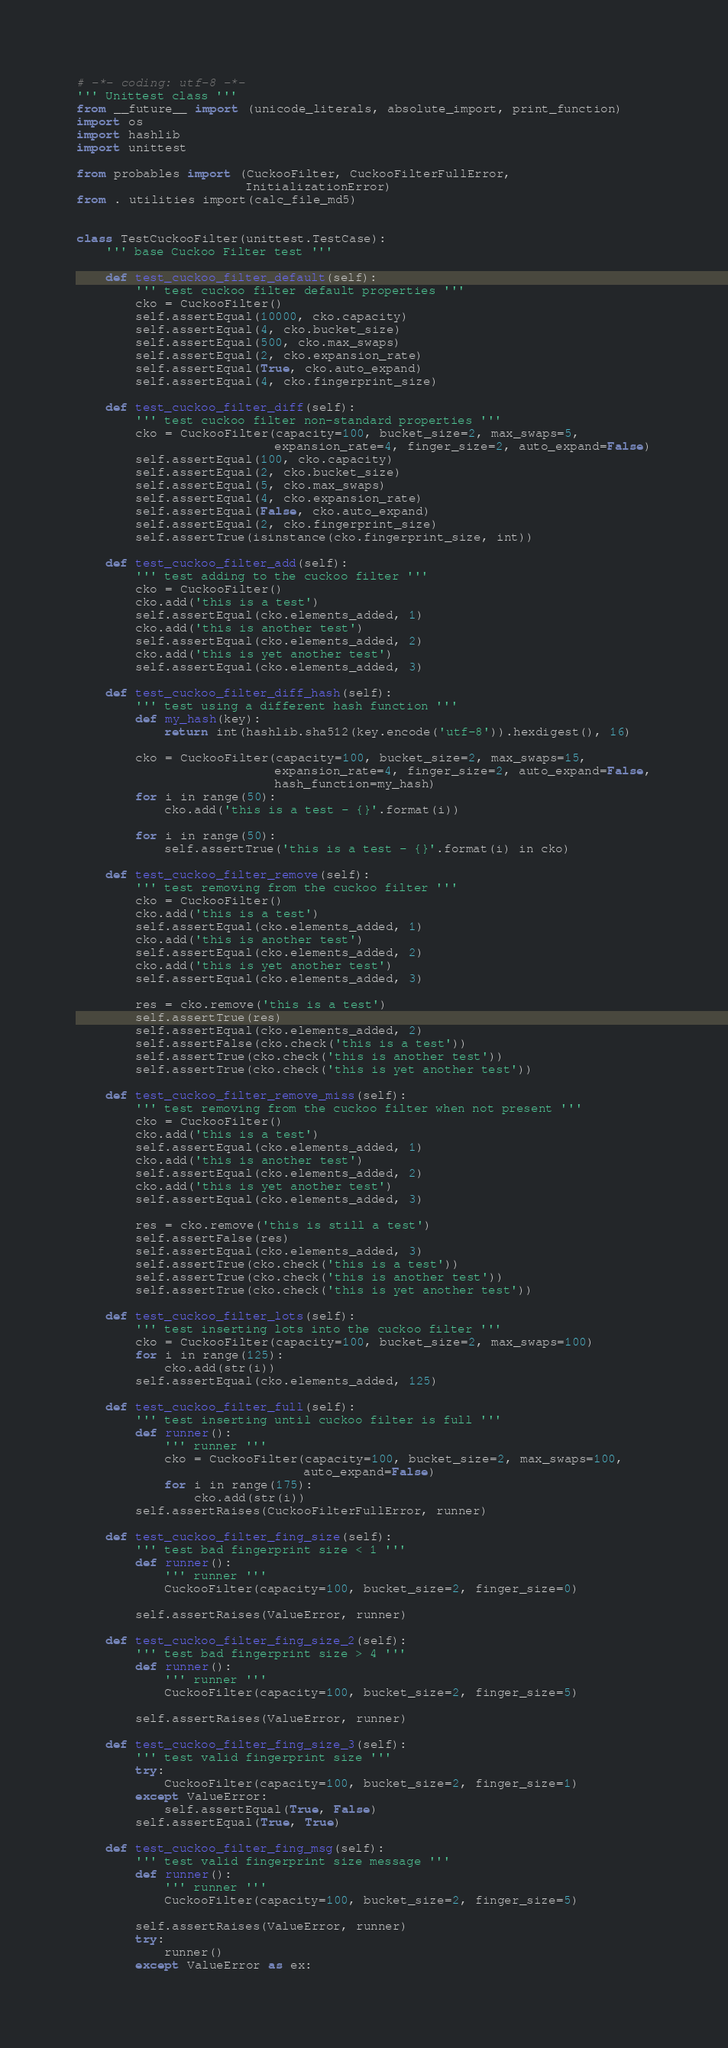Convert code to text. <code><loc_0><loc_0><loc_500><loc_500><_Python_># -*- coding: utf-8 -*-
''' Unittest class '''
from __future__ import (unicode_literals, absolute_import, print_function)
import os
import hashlib
import unittest

from probables import (CuckooFilter, CuckooFilterFullError,
                       InitializationError)
from . utilities import(calc_file_md5)


class TestCuckooFilter(unittest.TestCase):
    ''' base Cuckoo Filter test '''

    def test_cuckoo_filter_default(self):
        ''' test cuckoo filter default properties '''
        cko = CuckooFilter()
        self.assertEqual(10000, cko.capacity)
        self.assertEqual(4, cko.bucket_size)
        self.assertEqual(500, cko.max_swaps)
        self.assertEqual(2, cko.expansion_rate)
        self.assertEqual(True, cko.auto_expand)
        self.assertEqual(4, cko.fingerprint_size)

    def test_cuckoo_filter_diff(self):
        ''' test cuckoo filter non-standard properties '''
        cko = CuckooFilter(capacity=100, bucket_size=2, max_swaps=5,
                           expansion_rate=4, finger_size=2, auto_expand=False)
        self.assertEqual(100, cko.capacity)
        self.assertEqual(2, cko.bucket_size)
        self.assertEqual(5, cko.max_swaps)
        self.assertEqual(4, cko.expansion_rate)
        self.assertEqual(False, cko.auto_expand)
        self.assertEqual(2, cko.fingerprint_size)
        self.assertTrue(isinstance(cko.fingerprint_size, int))

    def test_cuckoo_filter_add(self):
        ''' test adding to the cuckoo filter '''
        cko = CuckooFilter()
        cko.add('this is a test')
        self.assertEqual(cko.elements_added, 1)
        cko.add('this is another test')
        self.assertEqual(cko.elements_added, 2)
        cko.add('this is yet another test')
        self.assertEqual(cko.elements_added, 3)

    def test_cuckoo_filter_diff_hash(self):
        ''' test using a different hash function '''
        def my_hash(key):
            return int(hashlib.sha512(key.encode('utf-8')).hexdigest(), 16)

        cko = CuckooFilter(capacity=100, bucket_size=2, max_swaps=15,
                           expansion_rate=4, finger_size=2, auto_expand=False,
                           hash_function=my_hash)
        for i in range(50):
            cko.add('this is a test - {}'.format(i))

        for i in range(50):
            self.assertTrue('this is a test - {}'.format(i) in cko)

    def test_cuckoo_filter_remove(self):
        ''' test removing from the cuckoo filter '''
        cko = CuckooFilter()
        cko.add('this is a test')
        self.assertEqual(cko.elements_added, 1)
        cko.add('this is another test')
        self.assertEqual(cko.elements_added, 2)
        cko.add('this is yet another test')
        self.assertEqual(cko.elements_added, 3)

        res = cko.remove('this is a test')
        self.assertTrue(res)
        self.assertEqual(cko.elements_added, 2)
        self.assertFalse(cko.check('this is a test'))
        self.assertTrue(cko.check('this is another test'))
        self.assertTrue(cko.check('this is yet another test'))

    def test_cuckoo_filter_remove_miss(self):
        ''' test removing from the cuckoo filter when not present '''
        cko = CuckooFilter()
        cko.add('this is a test')
        self.assertEqual(cko.elements_added, 1)
        cko.add('this is another test')
        self.assertEqual(cko.elements_added, 2)
        cko.add('this is yet another test')
        self.assertEqual(cko.elements_added, 3)

        res = cko.remove('this is still a test')
        self.assertFalse(res)
        self.assertEqual(cko.elements_added, 3)
        self.assertTrue(cko.check('this is a test'))
        self.assertTrue(cko.check('this is another test'))
        self.assertTrue(cko.check('this is yet another test'))

    def test_cuckoo_filter_lots(self):
        ''' test inserting lots into the cuckoo filter '''
        cko = CuckooFilter(capacity=100, bucket_size=2, max_swaps=100)
        for i in range(125):
            cko.add(str(i))
        self.assertEqual(cko.elements_added, 125)

    def test_cuckoo_filter_full(self):
        ''' test inserting until cuckoo filter is full '''
        def runner():
            ''' runner '''
            cko = CuckooFilter(capacity=100, bucket_size=2, max_swaps=100,
                               auto_expand=False)
            for i in range(175):
                cko.add(str(i))
        self.assertRaises(CuckooFilterFullError, runner)

    def test_cuckoo_filter_fing_size(self):
        ''' test bad fingerprint size < 1 '''
        def runner():
            ''' runner '''
            CuckooFilter(capacity=100, bucket_size=2, finger_size=0)

        self.assertRaises(ValueError, runner)

    def test_cuckoo_filter_fing_size_2(self):
        ''' test bad fingerprint size > 4 '''
        def runner():
            ''' runner '''
            CuckooFilter(capacity=100, bucket_size=2, finger_size=5)

        self.assertRaises(ValueError, runner)

    def test_cuckoo_filter_fing_size_3(self):
        ''' test valid fingerprint size '''
        try:
            CuckooFilter(capacity=100, bucket_size=2, finger_size=1)
        except ValueError:
            self.assertEqual(True, False)
        self.assertEqual(True, True)

    def test_cuckoo_filter_fing_msg(self):
        ''' test valid fingerprint size message '''
        def runner():
            ''' runner '''
            CuckooFilter(capacity=100, bucket_size=2, finger_size=5)

        self.assertRaises(ValueError, runner)
        try:
            runner()
        except ValueError as ex:</code> 